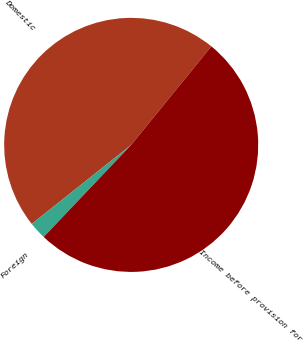Convert chart to OTSL. <chart><loc_0><loc_0><loc_500><loc_500><pie_chart><fcel>Domestic<fcel>Foreign<fcel>Income before provision for<nl><fcel>46.56%<fcel>2.22%<fcel>51.22%<nl></chart> 